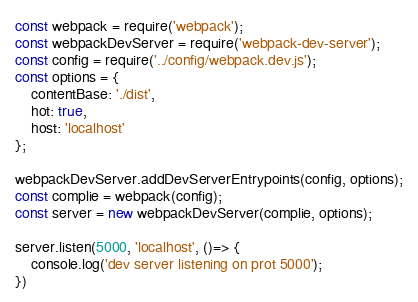<code> <loc_0><loc_0><loc_500><loc_500><_JavaScript_>const webpack = require('webpack');
const webpackDevServer = require('webpack-dev-server');
const config = require('../config/webpack.dev.js');
const options = {
	contentBase: './dist',
	hot: true,
	host: 'localhost'
};

webpackDevServer.addDevServerEntrypoints(config, options);
const complie = webpack(config);
const server = new webpackDevServer(complie, options);

server.listen(5000, 'localhost', ()=> {
	console.log('dev server listening on prot 5000');
})</code> 